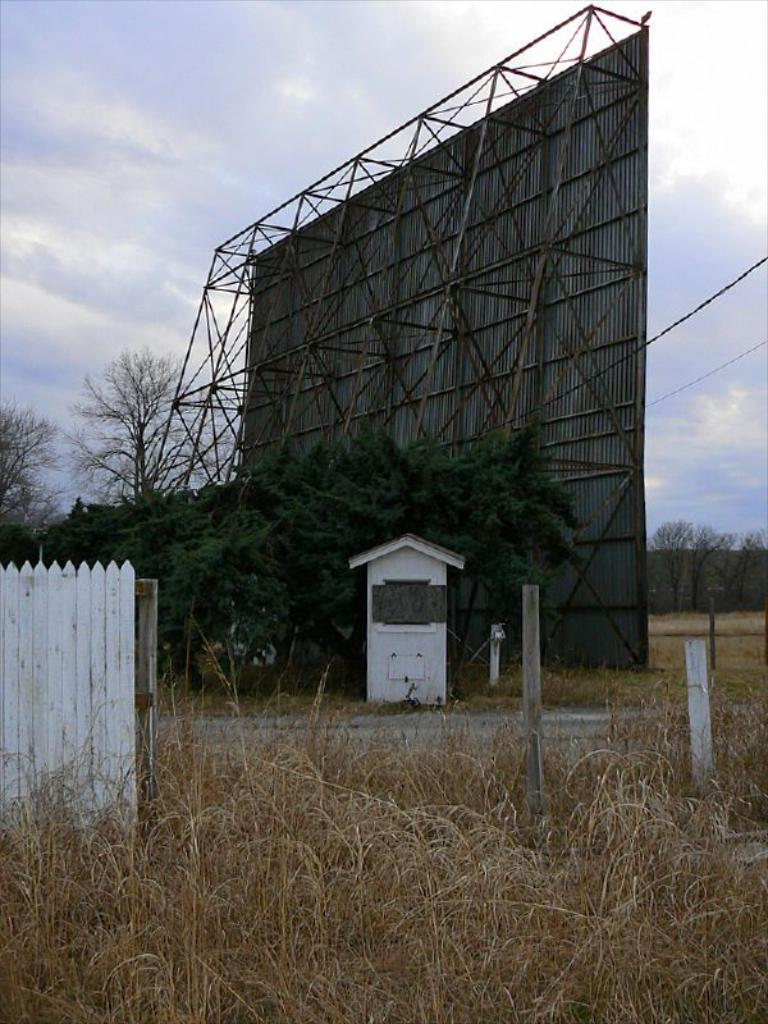What is the main structure in the image? There is a metal frame with a banner in the image. What type of building is visible in the image? There is a house with a roof in the image. What are the vertical supports in the image? There are poles in the image. What type of vegetation is present in the image? There are plants and a group of trees in the image. What type of barrier is visible in the image? There is a fence in the image. What other object can be seen in the image? There is a wire in the image. What is the condition of the sky in the image? The sky is visible in the image and appears cloudy. Can you see any quicksand in the image? No, there is no quicksand present in the image. What type of teaching is being conducted in the image? There is no teaching activity depicted in the image. 